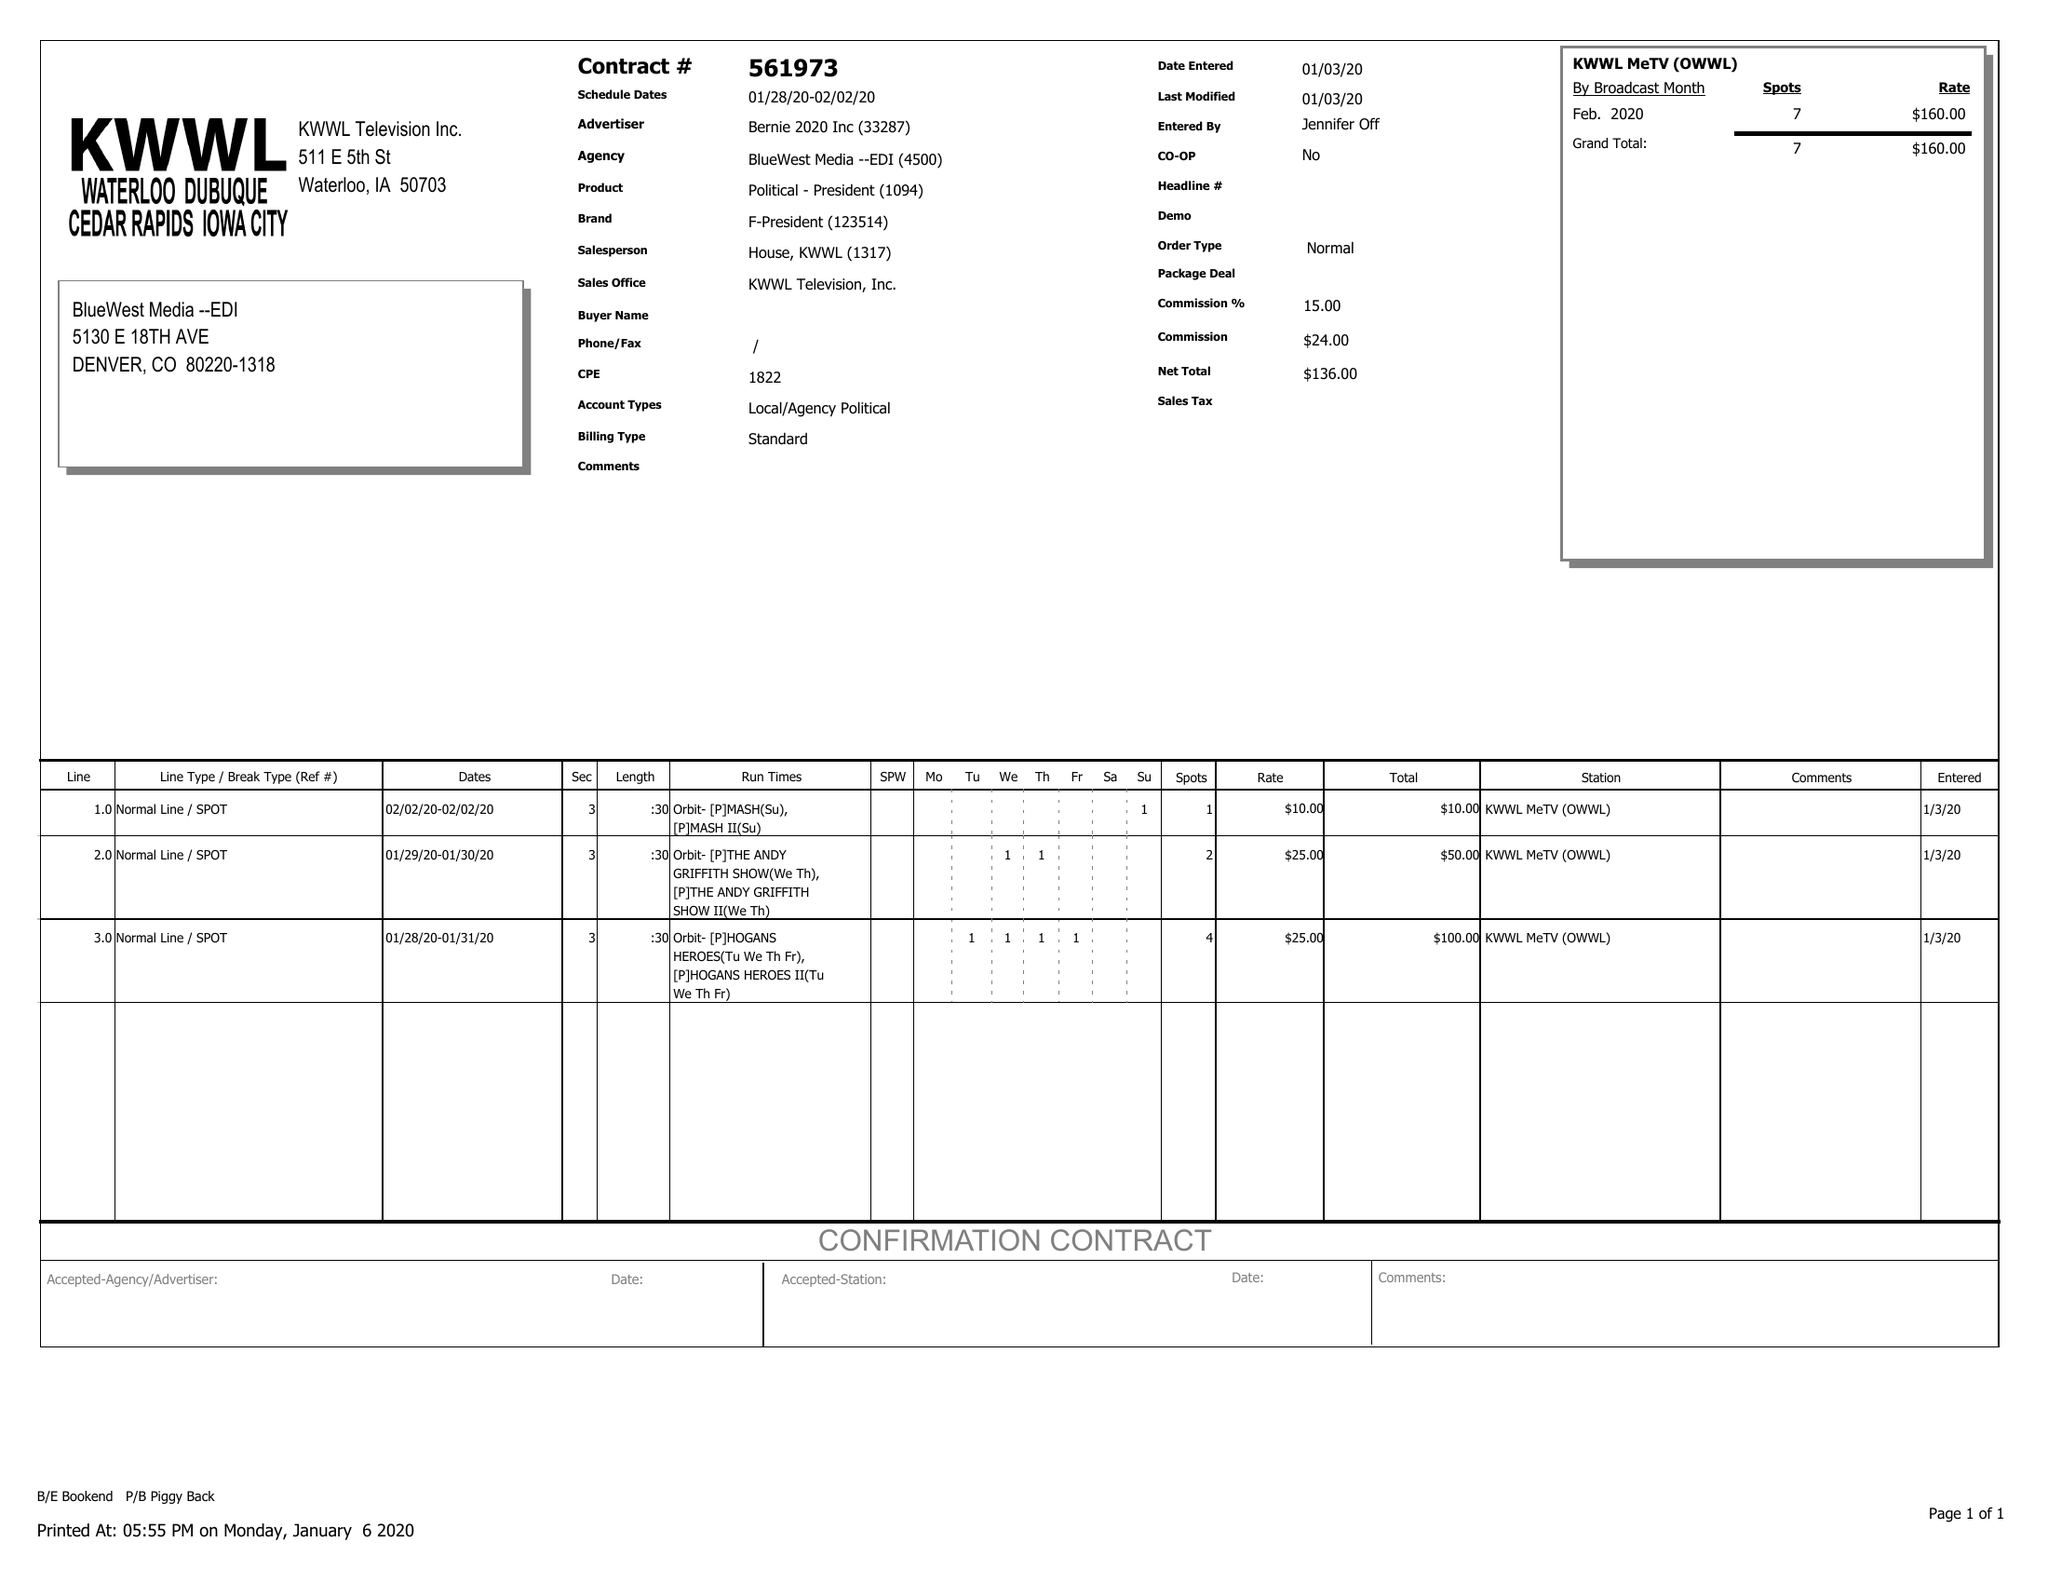What is the value for the gross_amount?
Answer the question using a single word or phrase. 160.00 